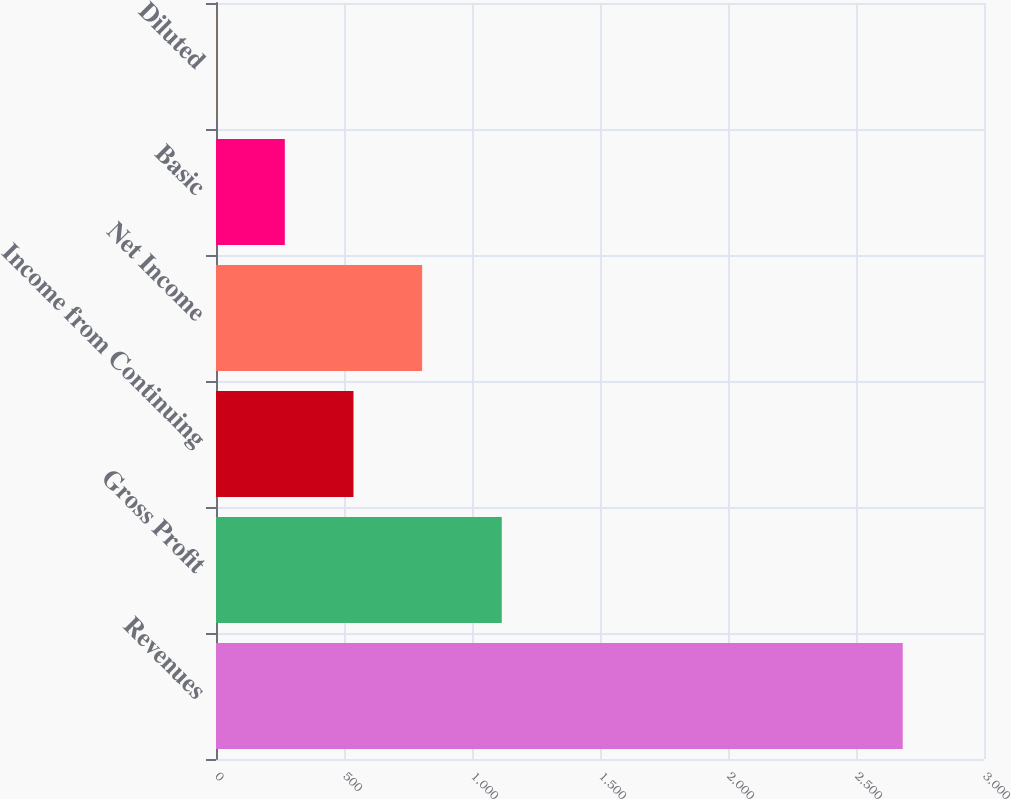<chart> <loc_0><loc_0><loc_500><loc_500><bar_chart><fcel>Revenues<fcel>Gross Profit<fcel>Income from Continuing<fcel>Net Income<fcel>Basic<fcel>Diluted<nl><fcel>2682.6<fcel>1116.3<fcel>537.03<fcel>805.23<fcel>268.83<fcel>0.63<nl></chart> 